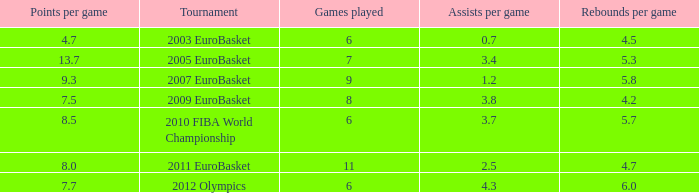How many games played have 4.7 as points per game? 6.0. 